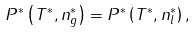<formula> <loc_0><loc_0><loc_500><loc_500>P ^ { \ast } \left ( T ^ { \ast } , n _ { g } ^ { \ast } \right ) = P ^ { \ast } \left ( T ^ { \ast } , n _ { l } ^ { \ast } \right ) ,</formula> 